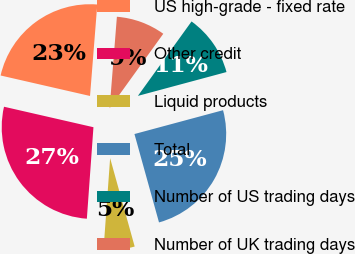Convert chart. <chart><loc_0><loc_0><loc_500><loc_500><pie_chart><fcel>US high-grade - fixed rate<fcel>Other credit<fcel>Liquid products<fcel>Total<fcel>Number of US trading days<fcel>Number of UK trading days<nl><fcel>22.68%<fcel>27.44%<fcel>5.46%<fcel>24.87%<fcel>10.88%<fcel>8.68%<nl></chart> 